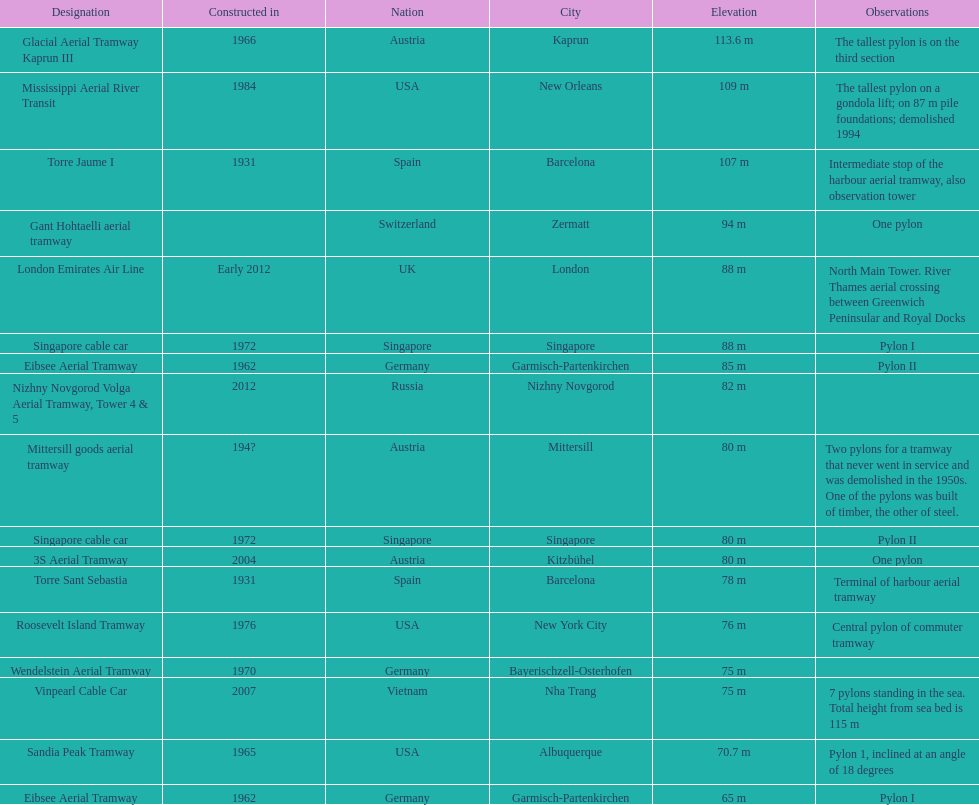How many metres is the tallest pylon? 113.6 m. 